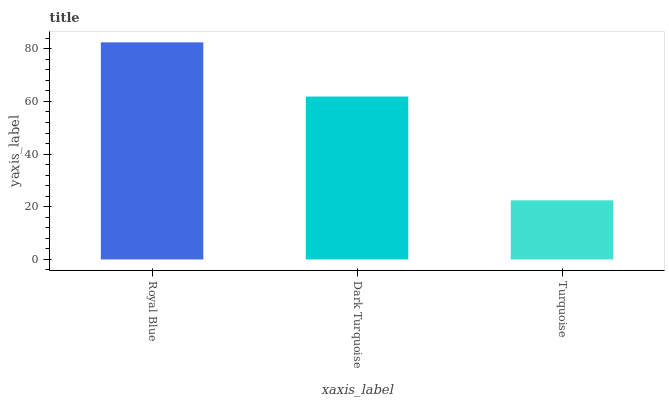Is Turquoise the minimum?
Answer yes or no. Yes. Is Royal Blue the maximum?
Answer yes or no. Yes. Is Dark Turquoise the minimum?
Answer yes or no. No. Is Dark Turquoise the maximum?
Answer yes or no. No. Is Royal Blue greater than Dark Turquoise?
Answer yes or no. Yes. Is Dark Turquoise less than Royal Blue?
Answer yes or no. Yes. Is Dark Turquoise greater than Royal Blue?
Answer yes or no. No. Is Royal Blue less than Dark Turquoise?
Answer yes or no. No. Is Dark Turquoise the high median?
Answer yes or no. Yes. Is Dark Turquoise the low median?
Answer yes or no. Yes. Is Turquoise the high median?
Answer yes or no. No. Is Royal Blue the low median?
Answer yes or no. No. 